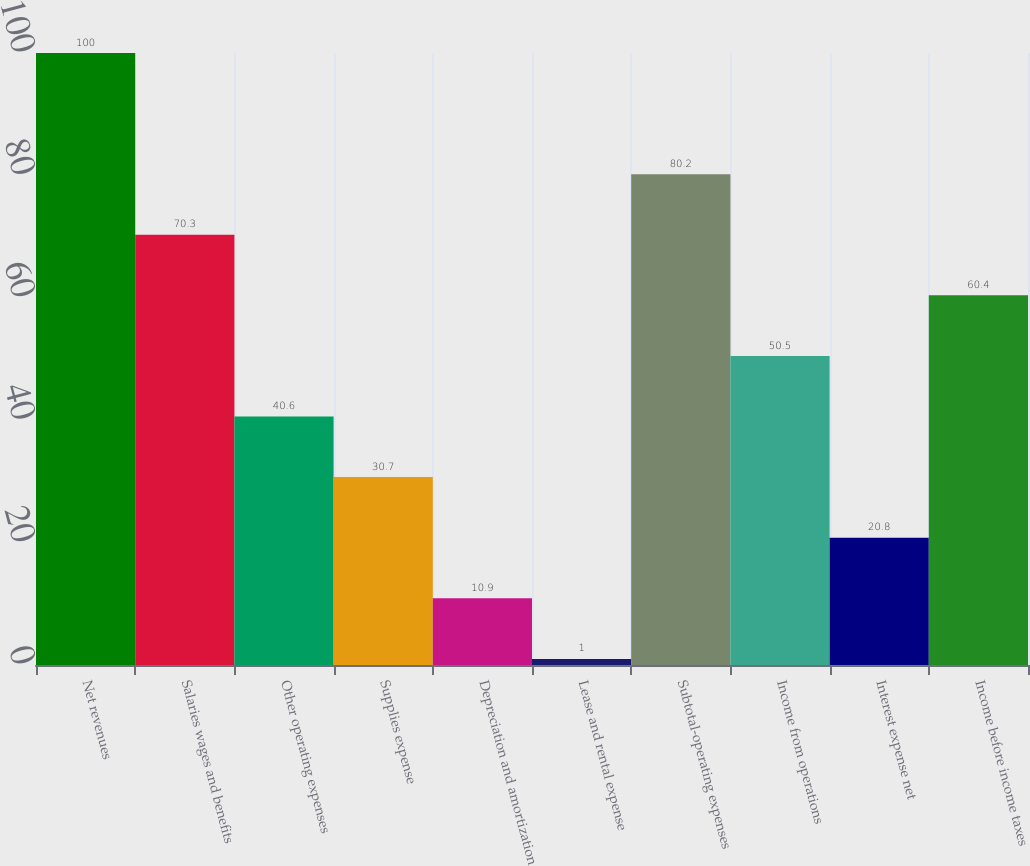Convert chart to OTSL. <chart><loc_0><loc_0><loc_500><loc_500><bar_chart><fcel>Net revenues<fcel>Salaries wages and benefits<fcel>Other operating expenses<fcel>Supplies expense<fcel>Depreciation and amortization<fcel>Lease and rental expense<fcel>Subtotal-operating expenses<fcel>Income from operations<fcel>Interest expense net<fcel>Income before income taxes<nl><fcel>100<fcel>70.3<fcel>40.6<fcel>30.7<fcel>10.9<fcel>1<fcel>80.2<fcel>50.5<fcel>20.8<fcel>60.4<nl></chart> 